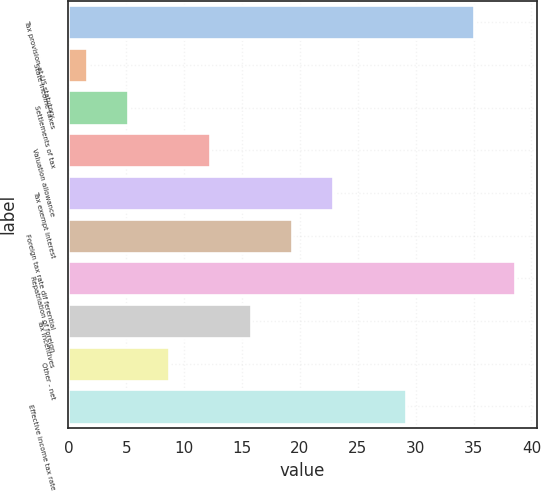Convert chart to OTSL. <chart><loc_0><loc_0><loc_500><loc_500><bar_chart><fcel>Tax provision at US statutory<fcel>State income taxes<fcel>Settlements of tax<fcel>Valuation allowance<fcel>Tax exempt interest<fcel>Foreign tax rate dif ferential<fcel>Repatriation of foreign<fcel>Tax incentives<fcel>Other - net<fcel>Effective income tax rate<nl><fcel>35<fcel>1.6<fcel>5.14<fcel>12.22<fcel>22.84<fcel>19.3<fcel>38.54<fcel>15.76<fcel>8.68<fcel>29.2<nl></chart> 